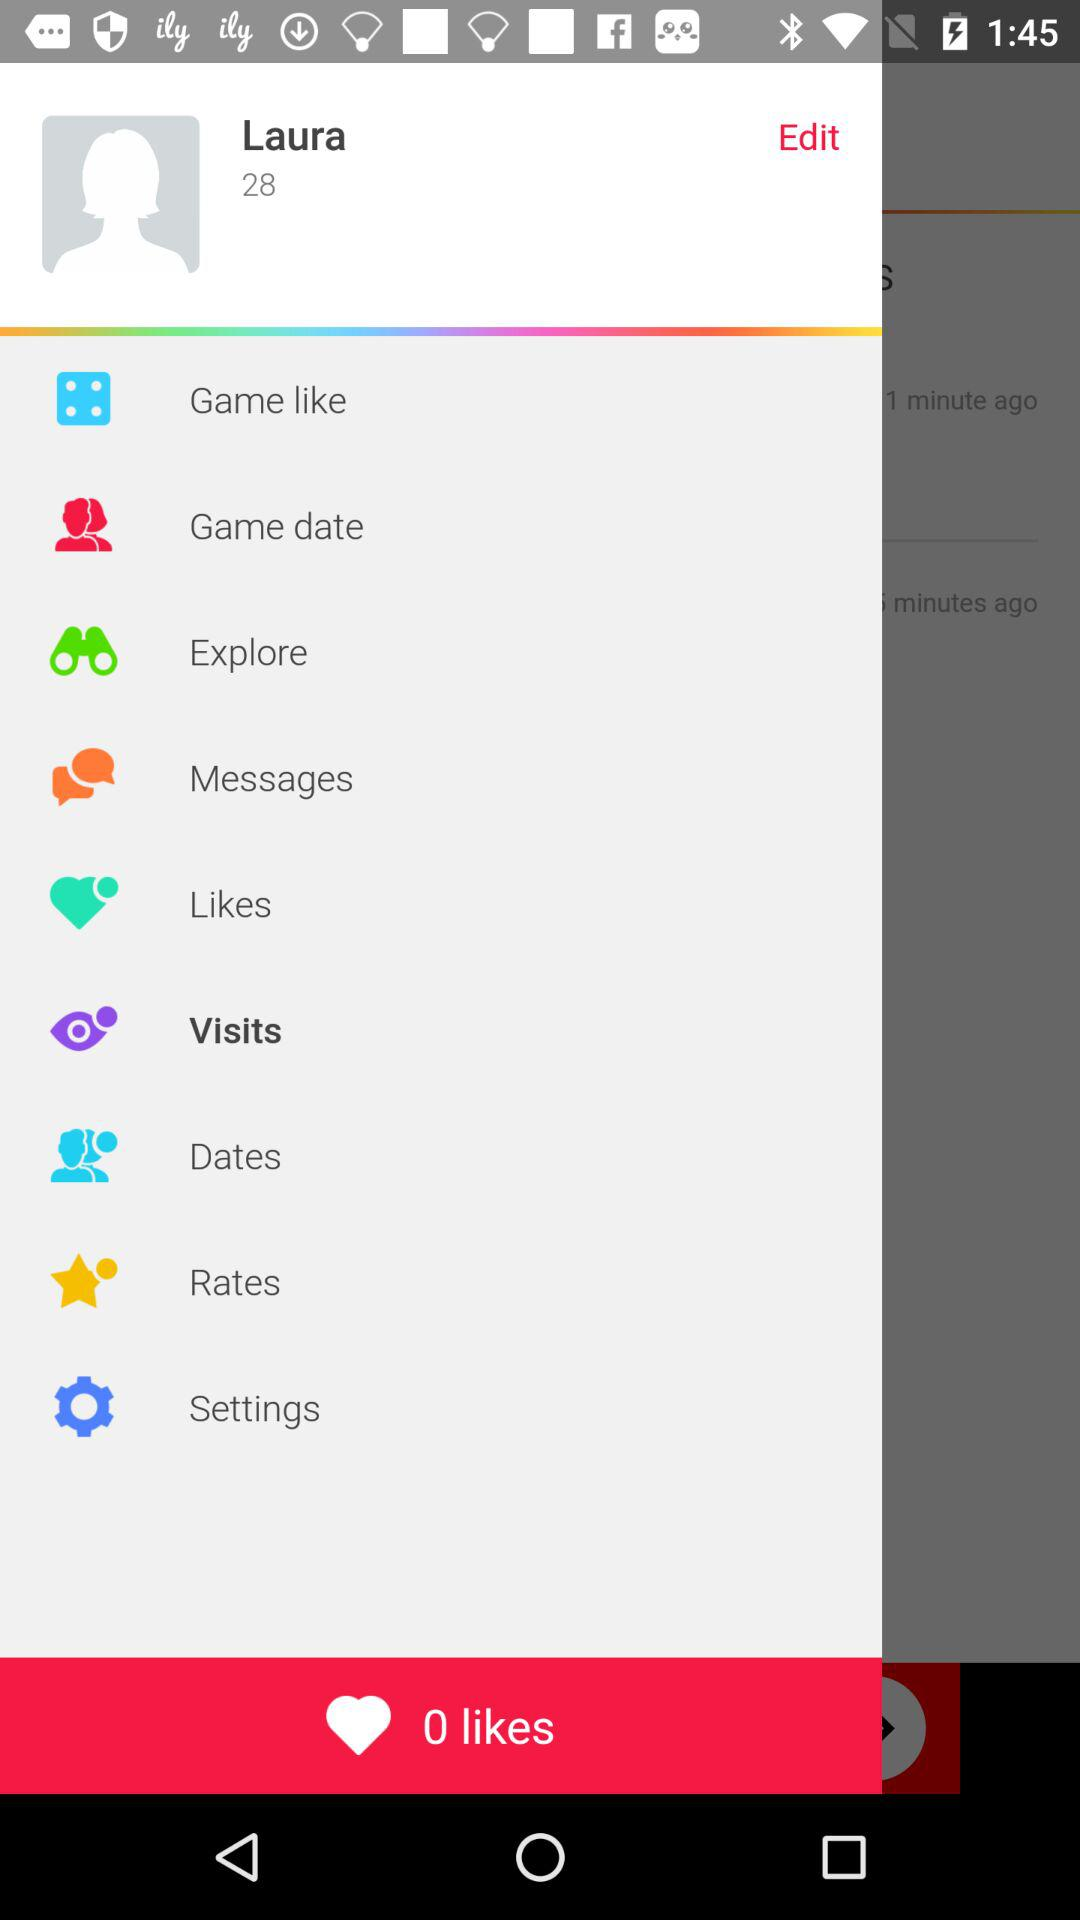How many likes are there? There are 0 likes. 